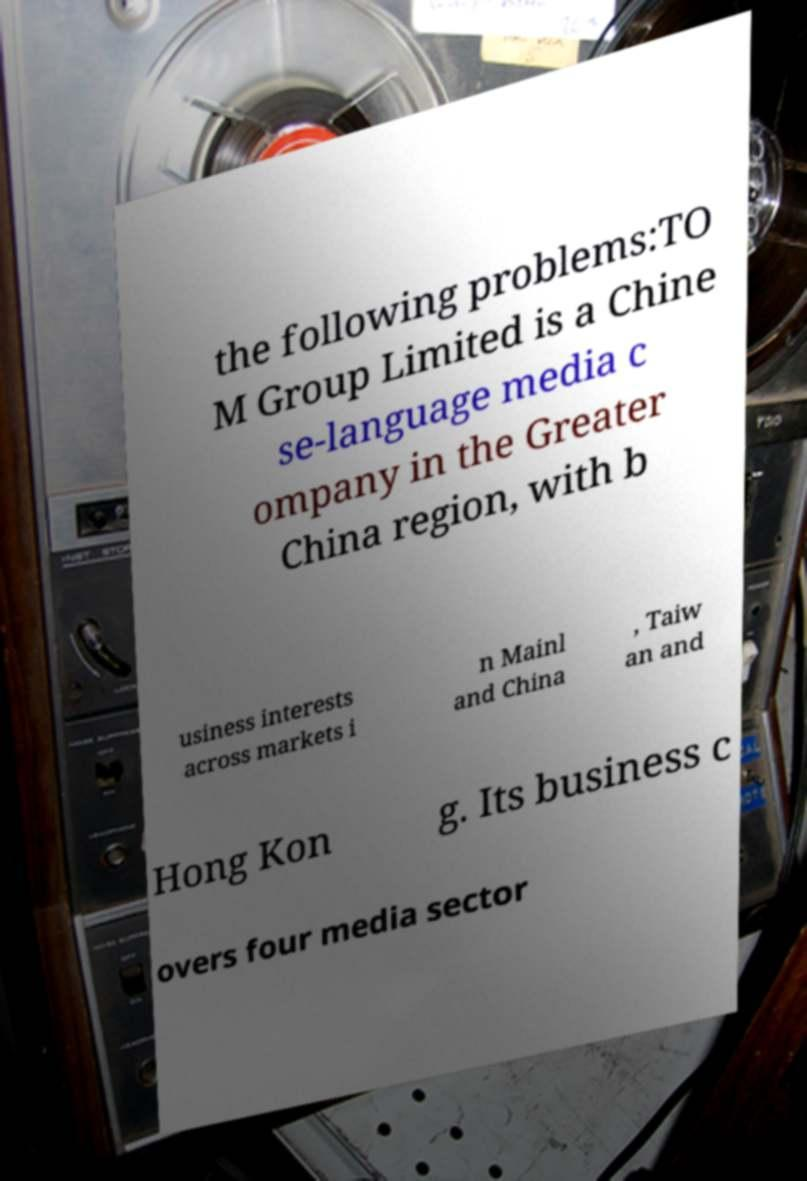Can you read and provide the text displayed in the image?This photo seems to have some interesting text. Can you extract and type it out for me? the following problems:TO M Group Limited is a Chine se-language media c ompany in the Greater China region, with b usiness interests across markets i n Mainl and China , Taiw an and Hong Kon g. Its business c overs four media sector 